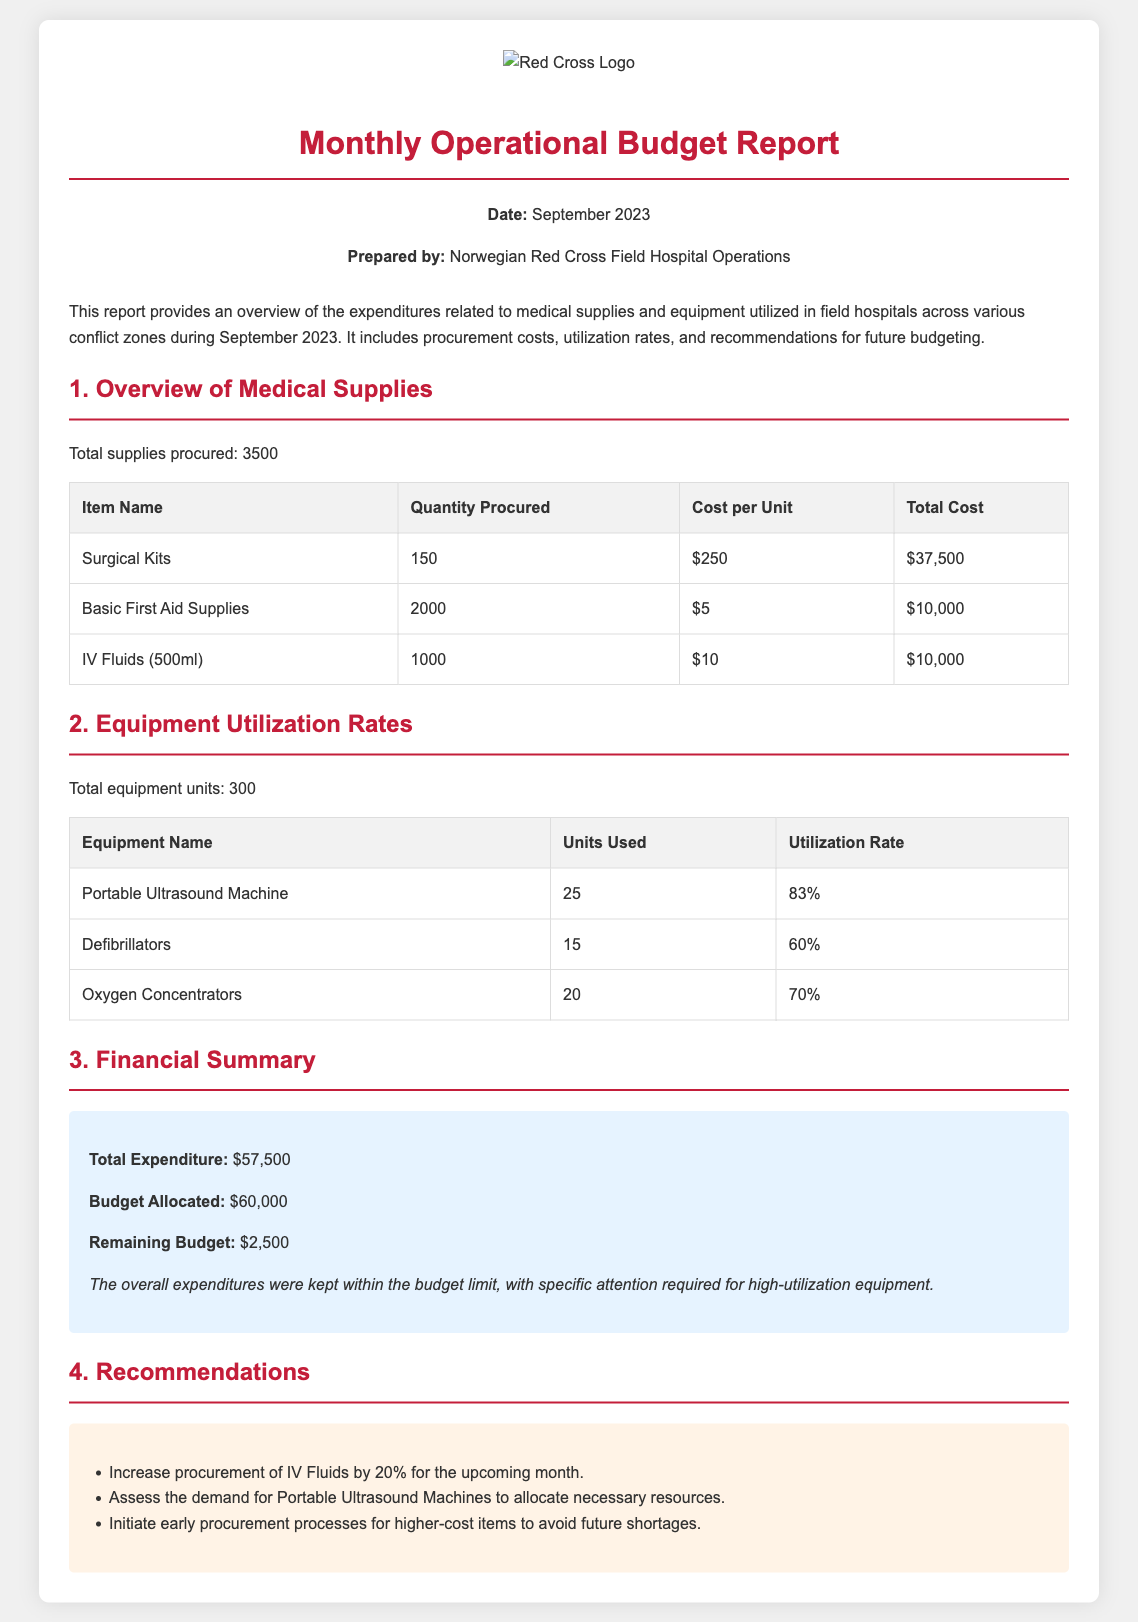What is the total number of supplies procured? The total number of supplies procured is stated in the overview section of the report.
Answer: 3500 What was the total cost of Surgical Kits? The total cost for Surgical Kits can be calculated from the table showing procurement details.
Answer: $37,500 What was the cost per unit of Basic First Aid Supplies? This information is available in the procurement costs table.
Answer: $5 What was the utilization rate of Defibrillators? Utilization rate details are provided in the equipment utilization rates section of the report.
Answer: 60% What is the total expenditure for September 2023? The total expenditure is mentioned in the financial summary section of the report.
Answer: $57,500 What percentage increase in procurement of IV Fluids is recommended? This information is given in the recommendations section.
Answer: 20% How many Portable Ultrasound Machines were used? This information can be found in the table detailing equipment utilization rates.
Answer: 25 What is the remaining budget after expenditures? The remaining budget is detailed in the financial summary section.
Answer: $2,500 What is the budget allocated for the month? This information is also found in the financial summary section of the report.
Answer: $60,000 